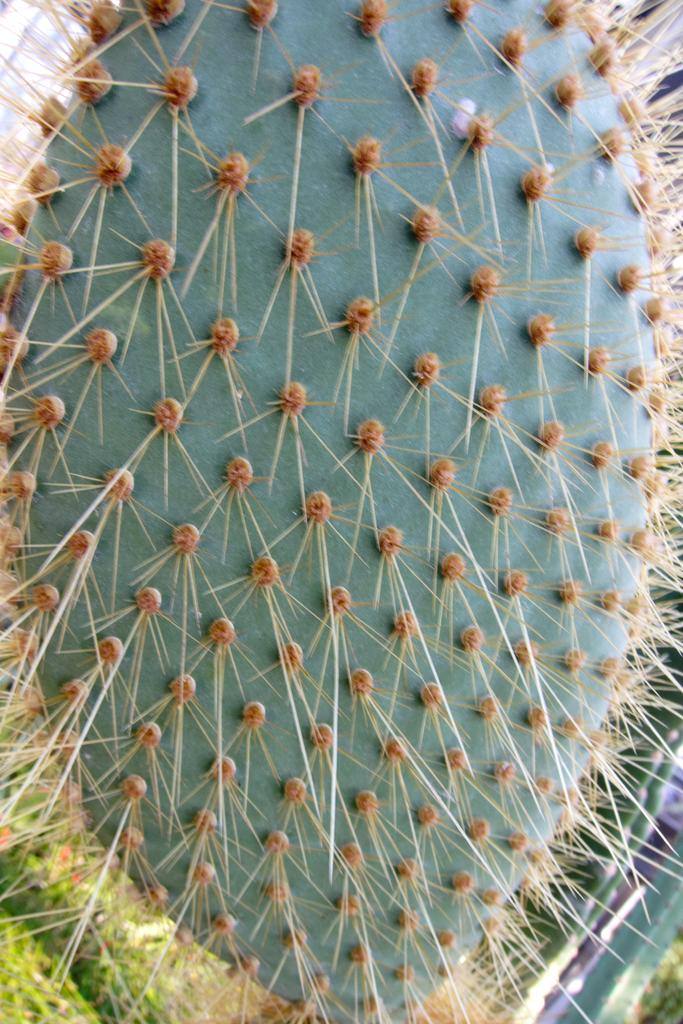What type of plant is in the image? There is a cactus plant in the image. What type of school is depicted in the image? There is no school present in the image; it only features a cactus plant. How many legs can be seen on the cactus plant in the image? Cactus plants do not have legs, so this question is not applicable to the image. 